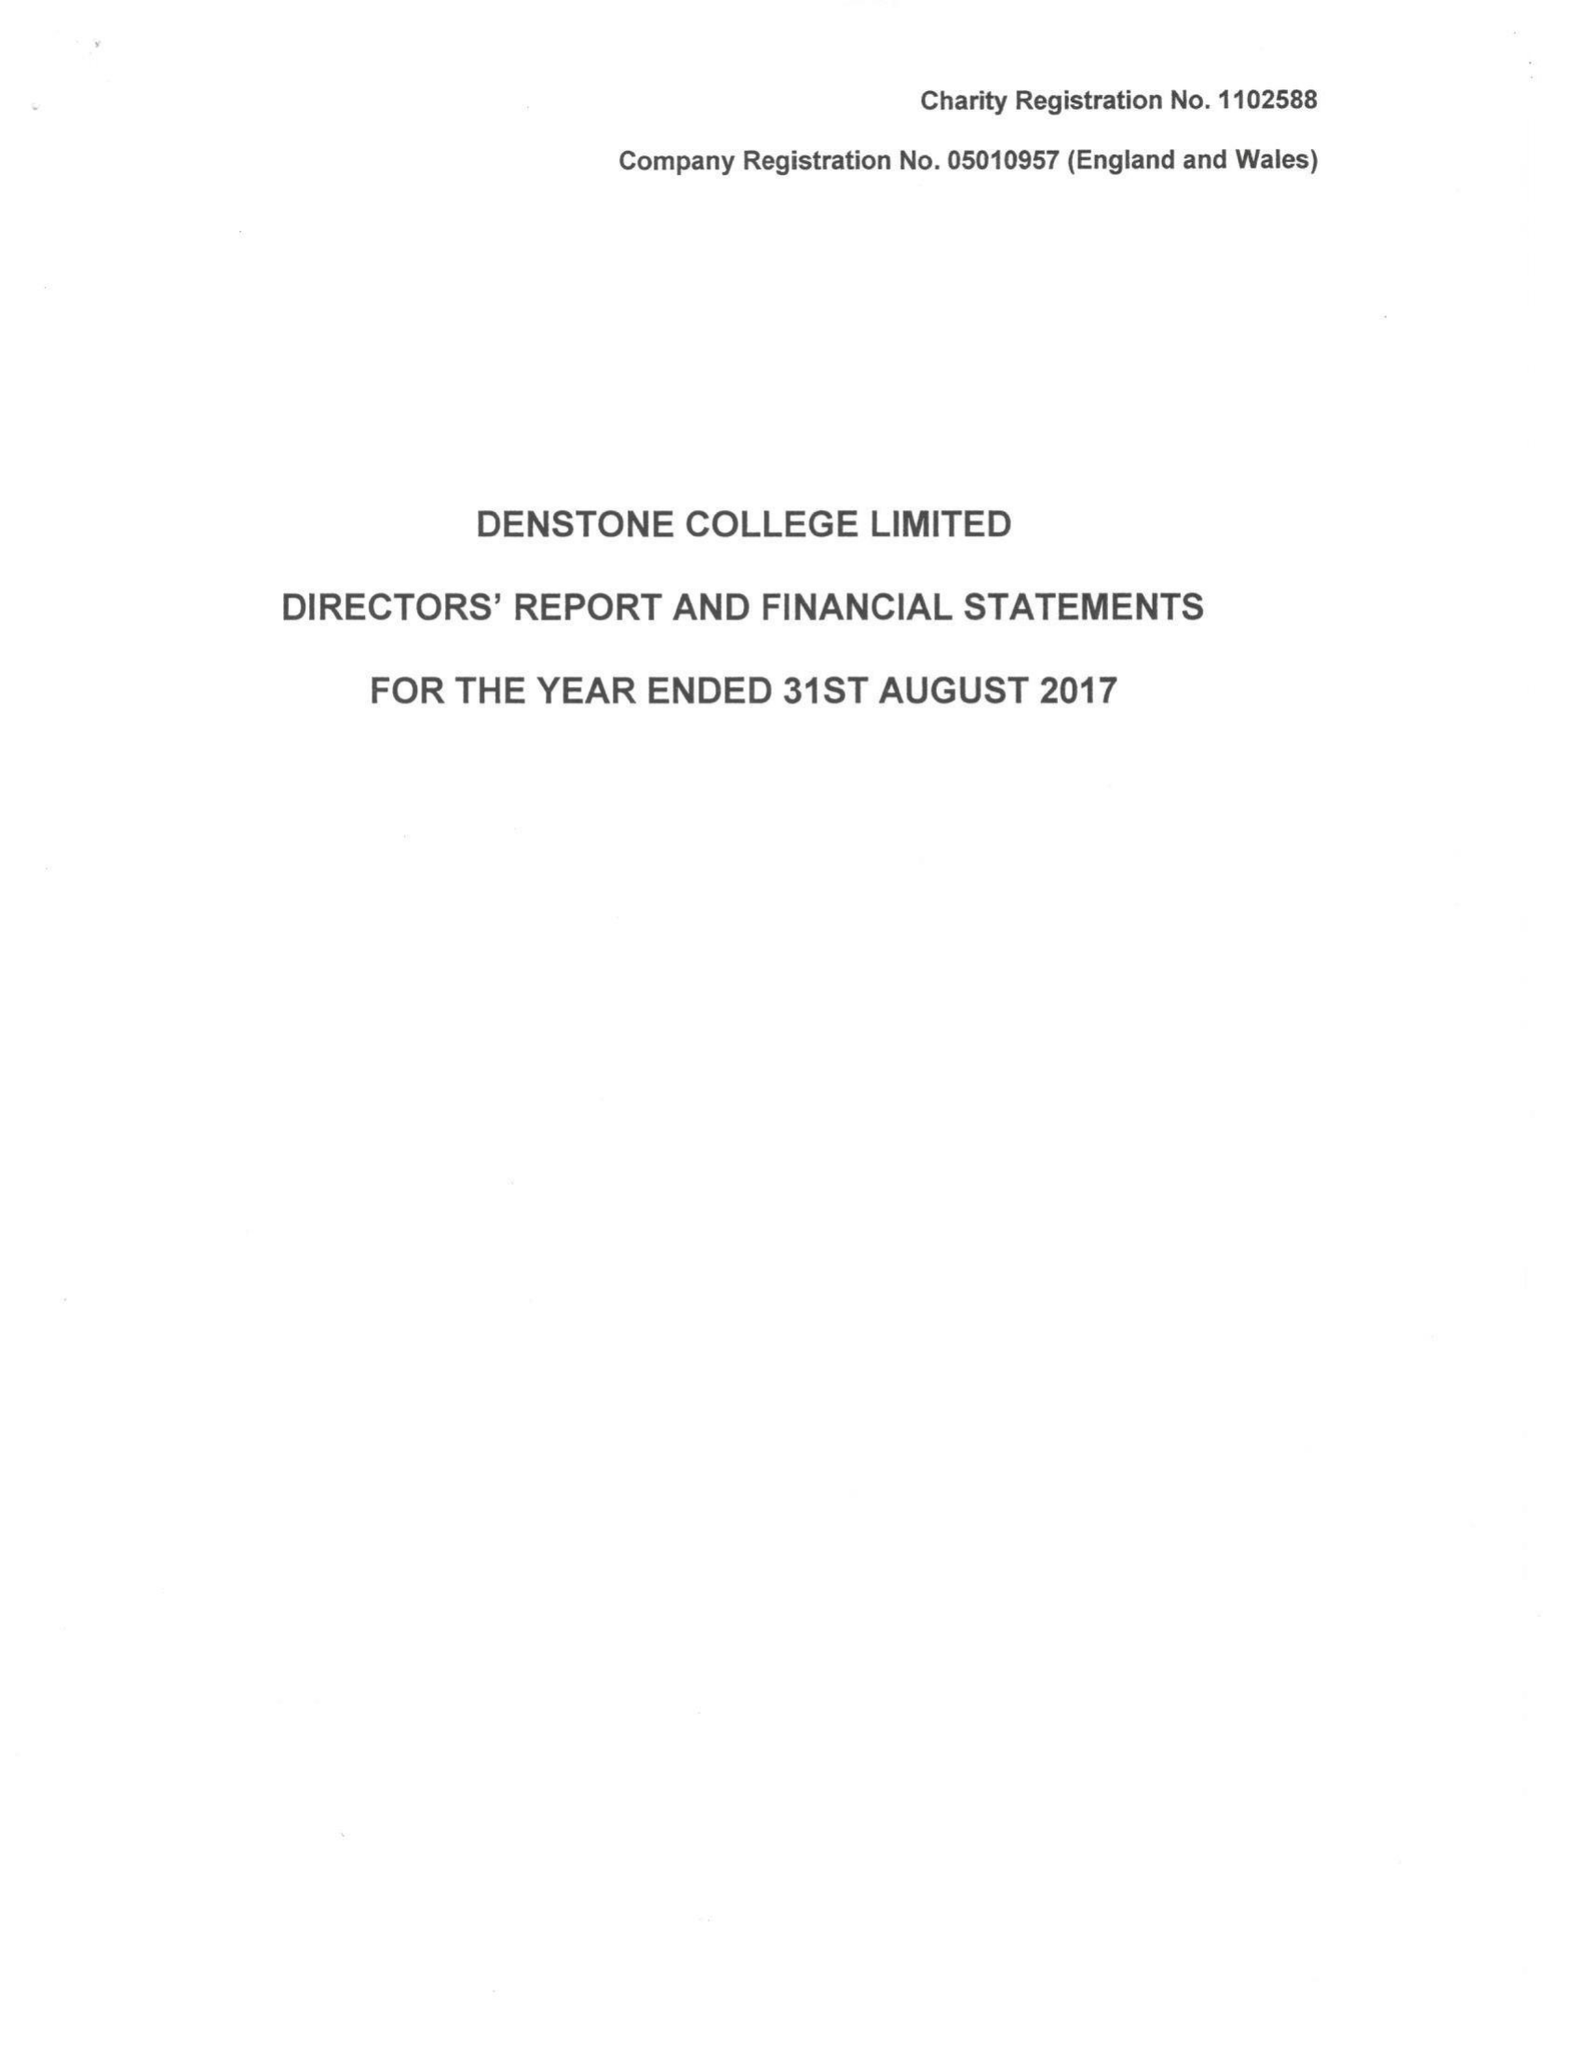What is the value for the charity_number?
Answer the question using a single word or phrase. 1102588 